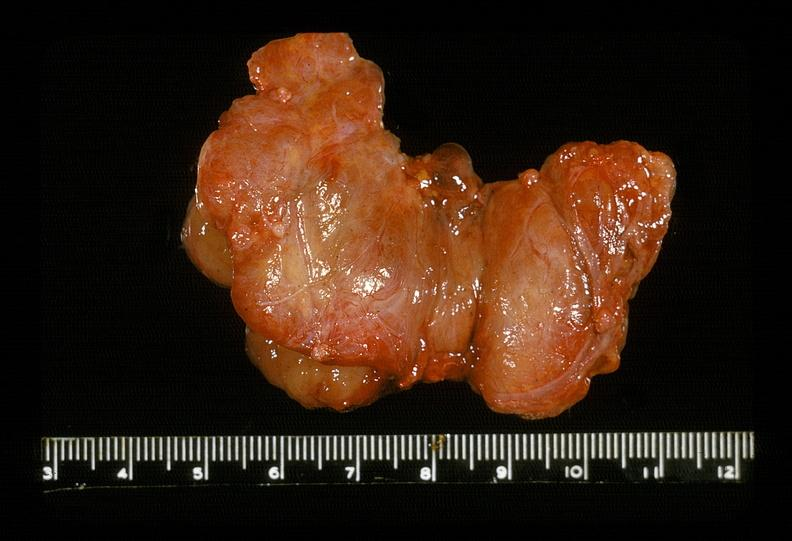s anomalous origin present?
Answer the question using a single word or phrase. No 